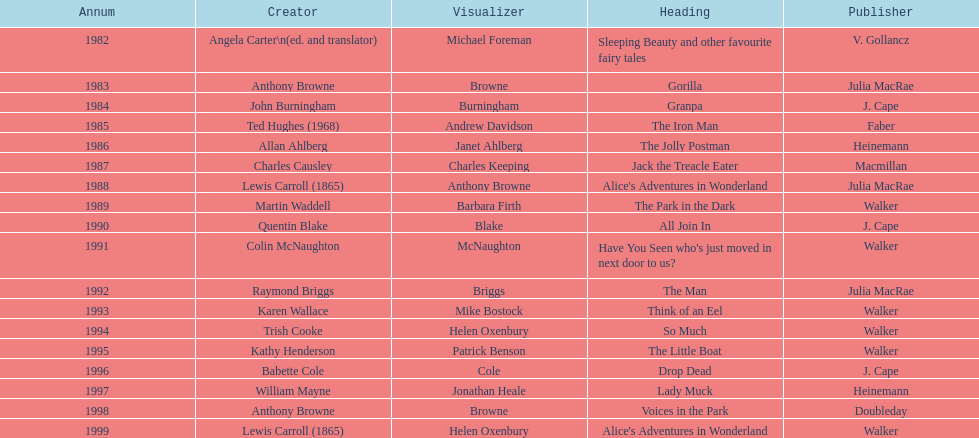How many titles did walker publish? 6. 